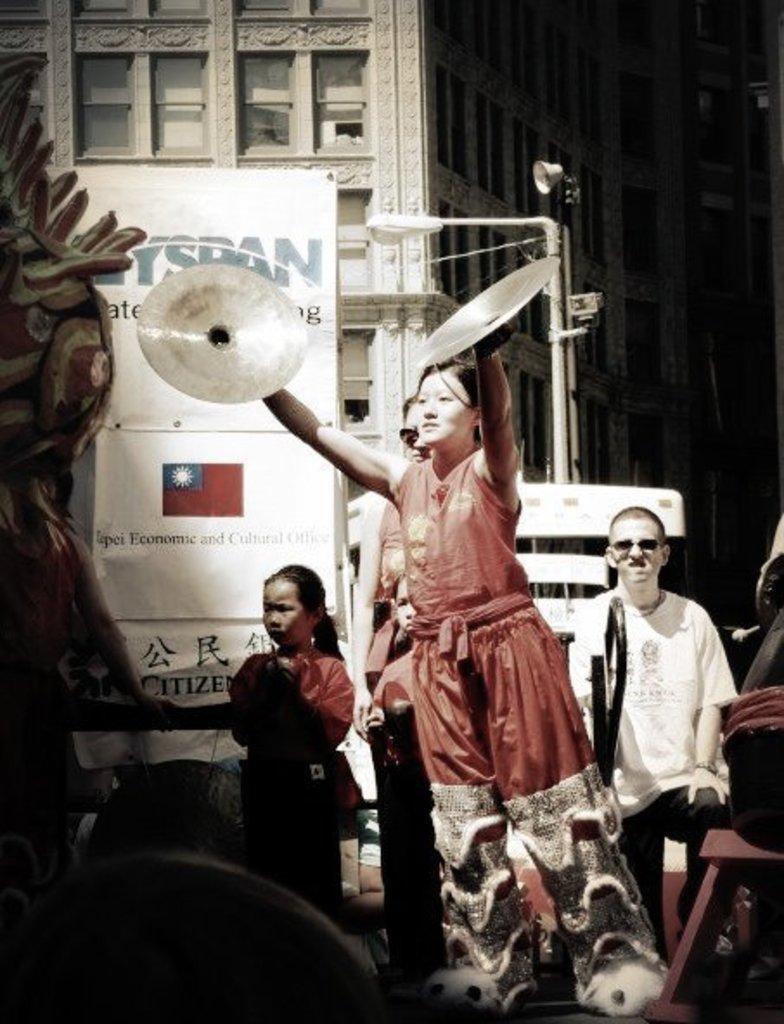Describe this image in one or two sentences. In this image we can see some persons, board and other objects. In the background of the image there is a building, poles and other objects. 